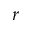Convert formula to latex. <formula><loc_0><loc_0><loc_500><loc_500>r</formula> 